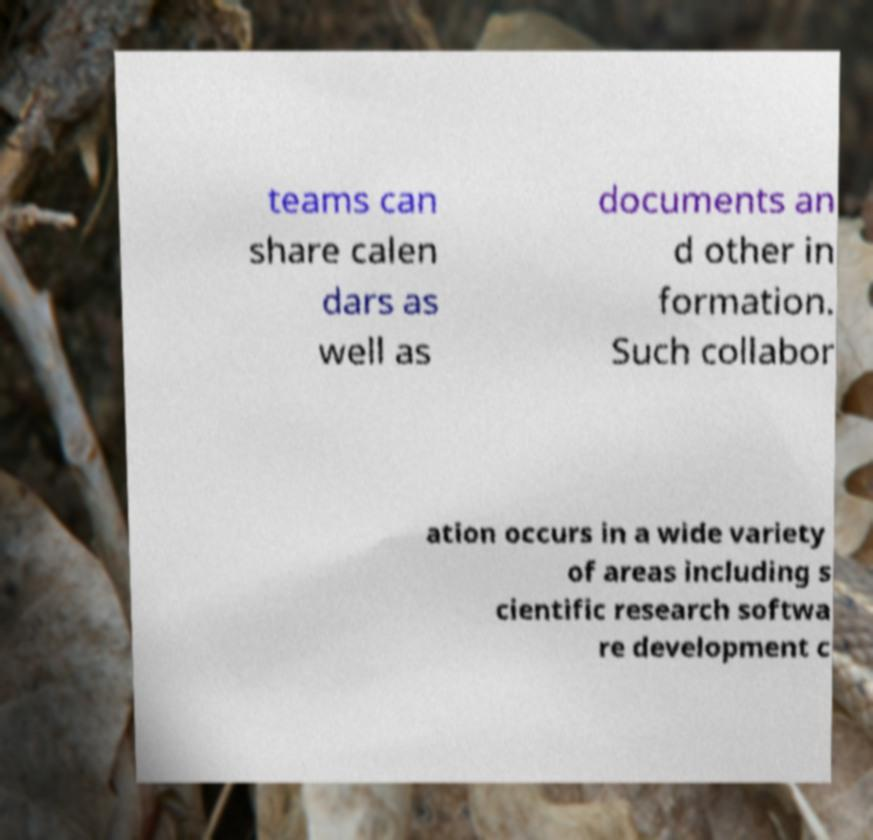Can you accurately transcribe the text from the provided image for me? teams can share calen dars as well as documents an d other in formation. Such collabor ation occurs in a wide variety of areas including s cientific research softwa re development c 